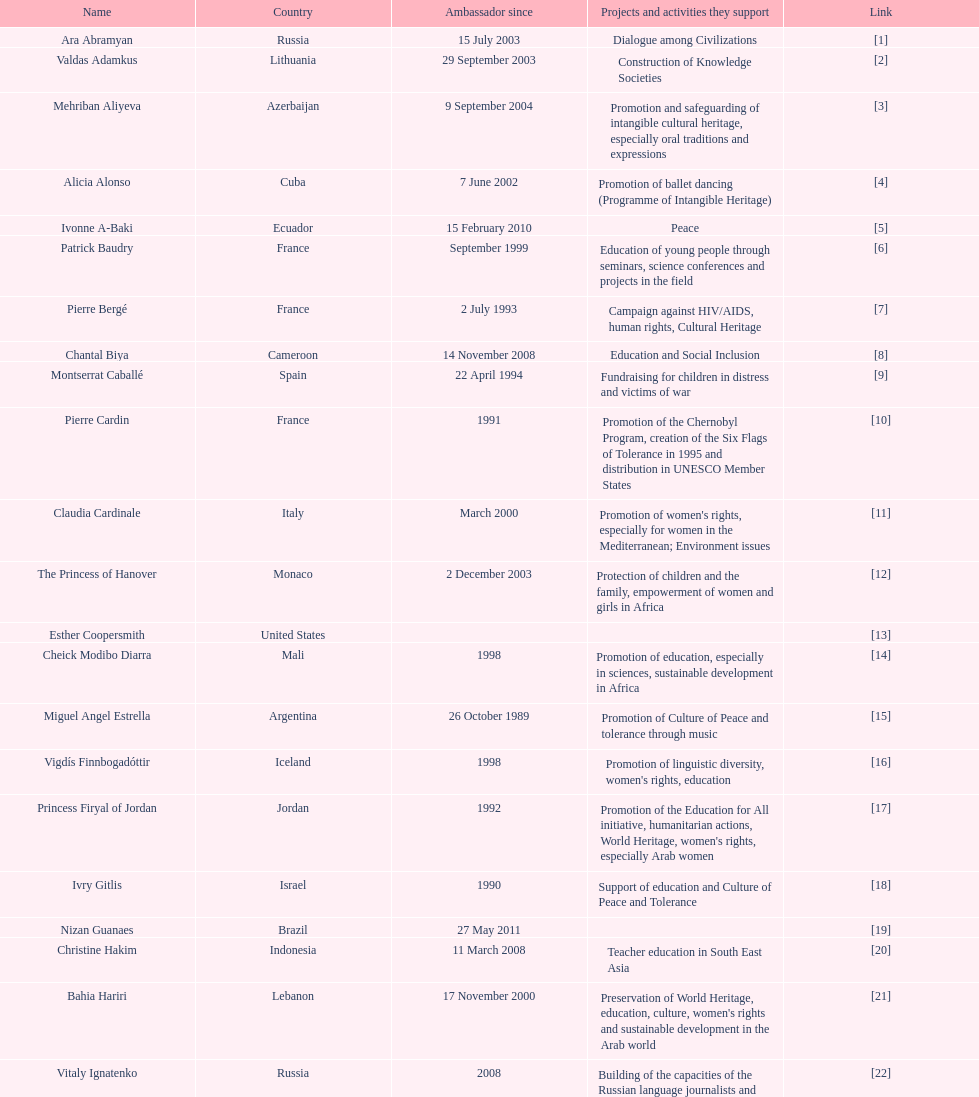Which unesco goodwill ambassador is most famed for supporting the chernobyl scheme? Pierre Cardin. 